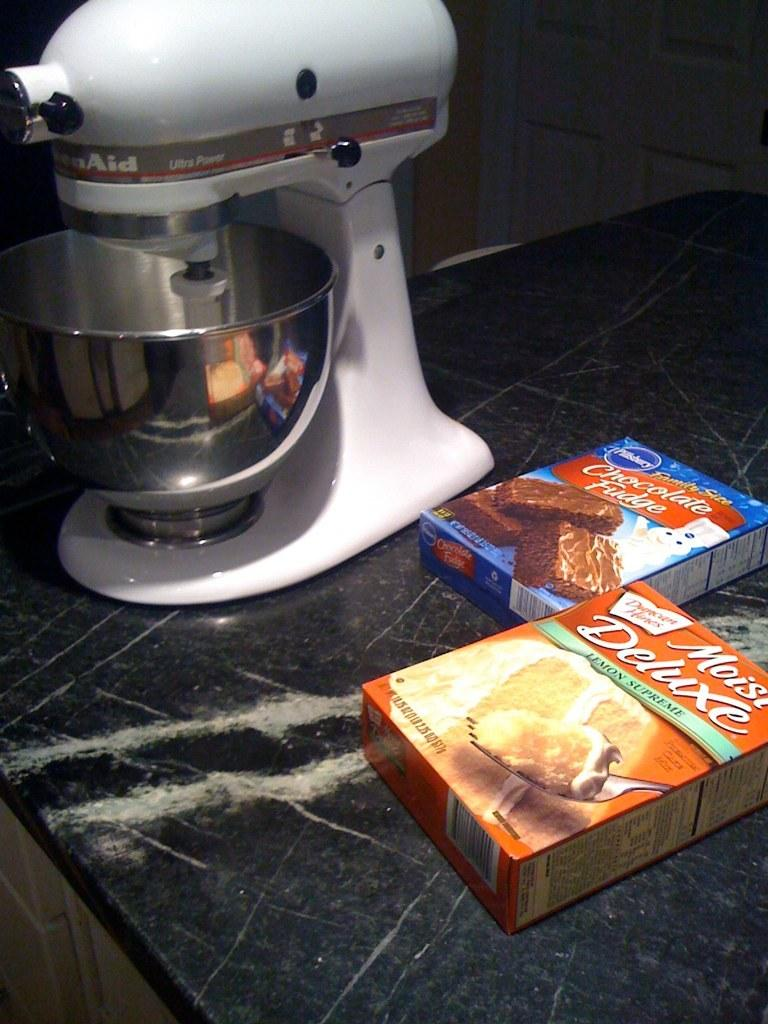<image>
Write a terse but informative summary of the picture. Two boxes of Pillsburry cake batter on a counter next to a Kitchen Aid mixer. 